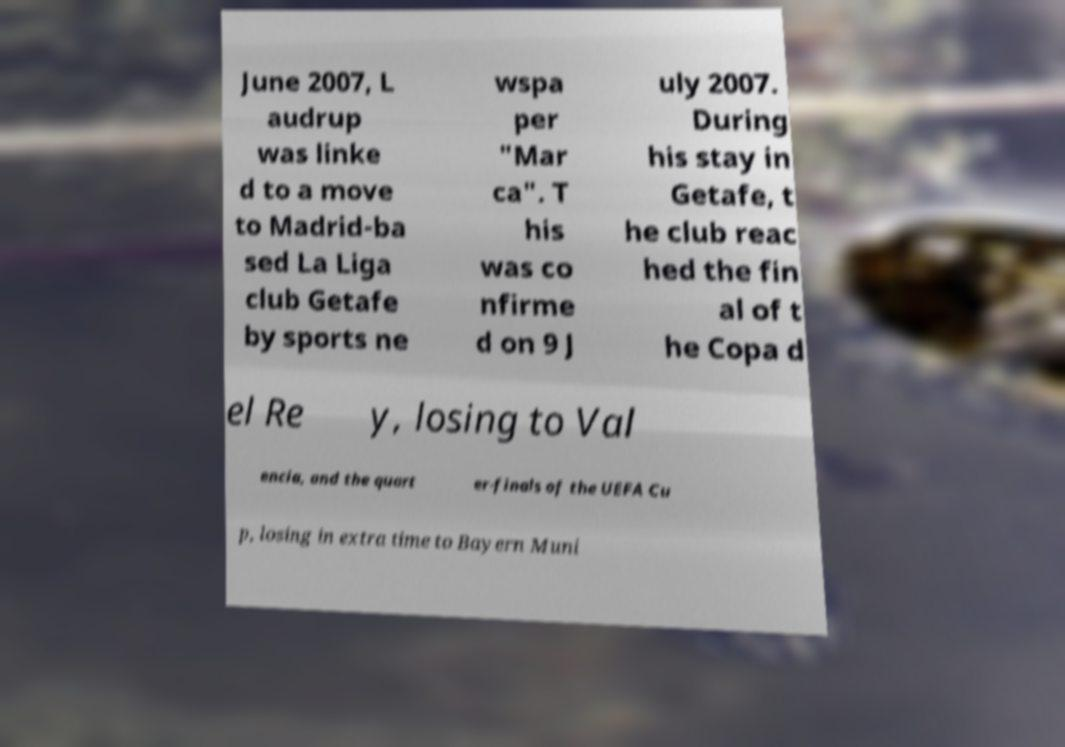Please read and relay the text visible in this image. What does it say? June 2007, L audrup was linke d to a move to Madrid-ba sed La Liga club Getafe by sports ne wspa per "Mar ca". T his was co nfirme d on 9 J uly 2007. During his stay in Getafe, t he club reac hed the fin al of t he Copa d el Re y, losing to Val encia, and the quart er-finals of the UEFA Cu p, losing in extra time to Bayern Muni 